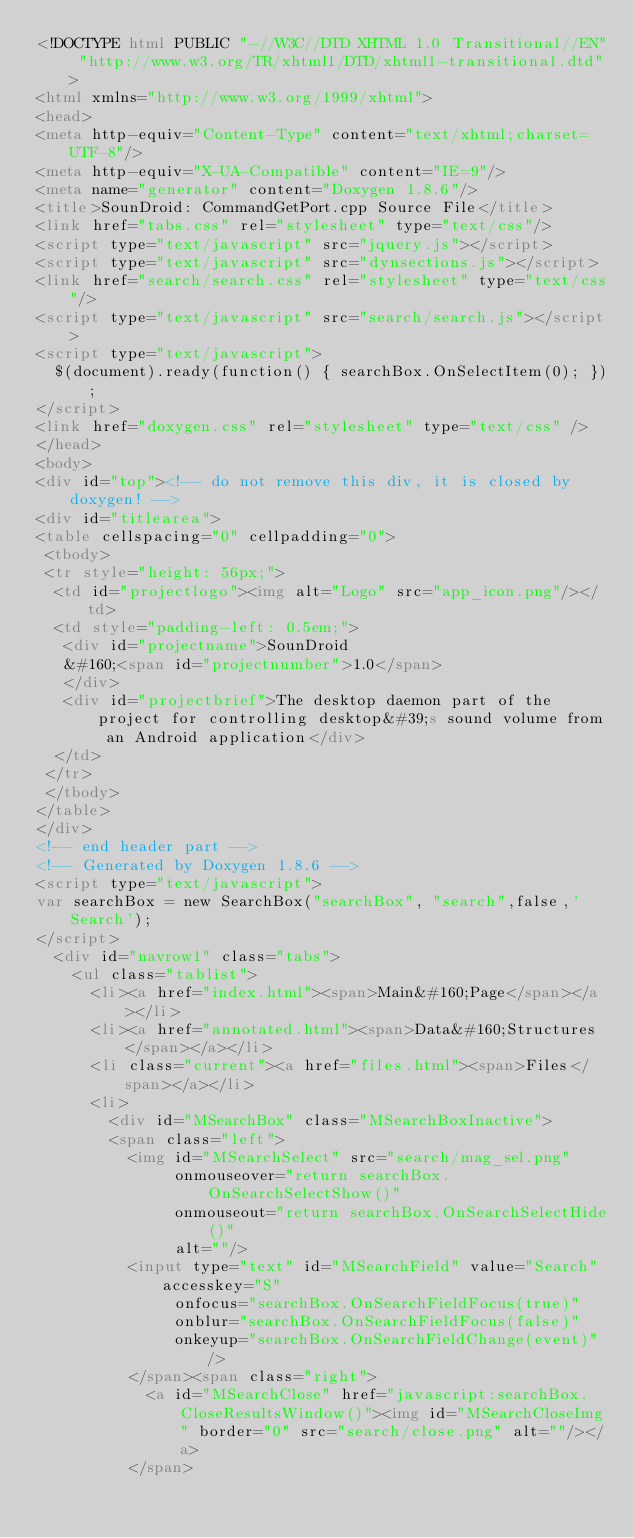Convert code to text. <code><loc_0><loc_0><loc_500><loc_500><_HTML_><!DOCTYPE html PUBLIC "-//W3C//DTD XHTML 1.0 Transitional//EN" "http://www.w3.org/TR/xhtml1/DTD/xhtml1-transitional.dtd">
<html xmlns="http://www.w3.org/1999/xhtml">
<head>
<meta http-equiv="Content-Type" content="text/xhtml;charset=UTF-8"/>
<meta http-equiv="X-UA-Compatible" content="IE=9"/>
<meta name="generator" content="Doxygen 1.8.6"/>
<title>SounDroid: CommandGetPort.cpp Source File</title>
<link href="tabs.css" rel="stylesheet" type="text/css"/>
<script type="text/javascript" src="jquery.js"></script>
<script type="text/javascript" src="dynsections.js"></script>
<link href="search/search.css" rel="stylesheet" type="text/css"/>
<script type="text/javascript" src="search/search.js"></script>
<script type="text/javascript">
  $(document).ready(function() { searchBox.OnSelectItem(0); });
</script>
<link href="doxygen.css" rel="stylesheet" type="text/css" />
</head>
<body>
<div id="top"><!-- do not remove this div, it is closed by doxygen! -->
<div id="titlearea">
<table cellspacing="0" cellpadding="0">
 <tbody>
 <tr style="height: 56px;">
  <td id="projectlogo"><img alt="Logo" src="app_icon.png"/></td>
  <td style="padding-left: 0.5em;">
   <div id="projectname">SounDroid
   &#160;<span id="projectnumber">1.0</span>
   </div>
   <div id="projectbrief">The desktop daemon part of the project for controlling desktop&#39;s sound volume from an Android application</div>
  </td>
 </tr>
 </tbody>
</table>
</div>
<!-- end header part -->
<!-- Generated by Doxygen 1.8.6 -->
<script type="text/javascript">
var searchBox = new SearchBox("searchBox", "search",false,'Search');
</script>
  <div id="navrow1" class="tabs">
    <ul class="tablist">
      <li><a href="index.html"><span>Main&#160;Page</span></a></li>
      <li><a href="annotated.html"><span>Data&#160;Structures</span></a></li>
      <li class="current"><a href="files.html"><span>Files</span></a></li>
      <li>
        <div id="MSearchBox" class="MSearchBoxInactive">
        <span class="left">
          <img id="MSearchSelect" src="search/mag_sel.png"
               onmouseover="return searchBox.OnSearchSelectShow()"
               onmouseout="return searchBox.OnSearchSelectHide()"
               alt=""/>
          <input type="text" id="MSearchField" value="Search" accesskey="S"
               onfocus="searchBox.OnSearchFieldFocus(true)" 
               onblur="searchBox.OnSearchFieldFocus(false)" 
               onkeyup="searchBox.OnSearchFieldChange(event)"/>
          </span><span class="right">
            <a id="MSearchClose" href="javascript:searchBox.CloseResultsWindow()"><img id="MSearchCloseImg" border="0" src="search/close.png" alt=""/></a>
          </span></code> 